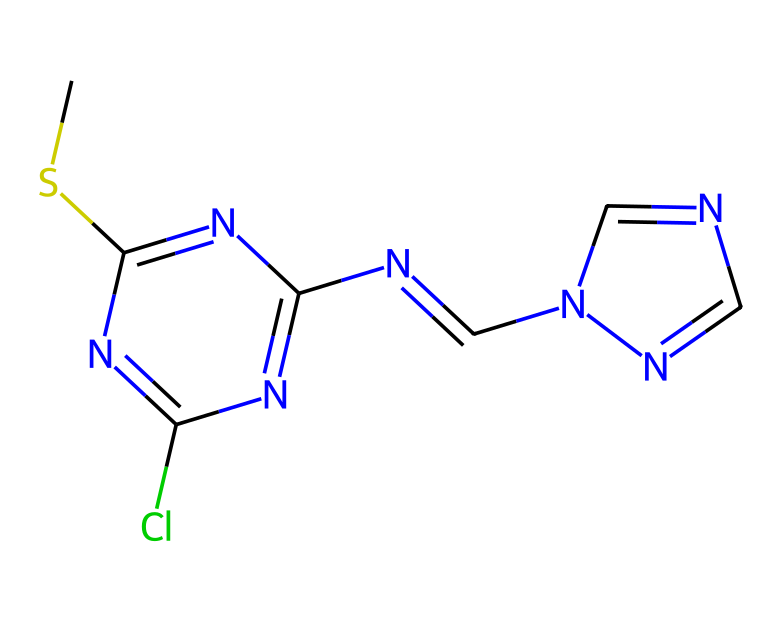What is the number of nitrogen atoms in this structure? By examining the SMILES representation, we can see that there are four nitrogen atoms represented by the "N" letters in the structure.
Answer: four What type of functional groups are present in this compound? The structure contains a thiourea functional group due to the presence of sulfur bonded to carbon and nitrogen groups, alongside multiple imine groups, indicated by the nitrogen atoms bonded to carbon in a double bond format.
Answer: thiourea How many carbon atoms are in this chemical? Counting the "C" characters in the SMILES and taking into account the representation of carbon within rings also leads to a total of seven carbon atoms.
Answer: seven What element is likely the main reactive site in this compound? The presence of multiple nitrogen atoms bonded to a carbon structure typically indicates that the compound might exhibit nucleophilic behavior coming from the lone pair of electrons on the nitrogen, making it likely the main reactive site.
Answer: nitrogen What type of pharmacological activity might this compound exhibit? Considering the structure's complexity with multiple nitrogen and sulfur components, this compound has the potential to exhibit antimicrobial activity, often associated with fungicidal properties.
Answer: fungicidal How many rings are present in the structure? Upon analyzing the SMILES representation, we can identify two distinct ring structures due to the presence of two occurrences of "C=N" linking the nitrogen atoms, indicating ring formation.
Answer: two What type of compound is this most closely related to in terms of its action as a fungicide? The structure shares characteristics with carbamate fungicides, known for their ability to disrupt vital biochemical pathways in fungi.
Answer: carbamate 